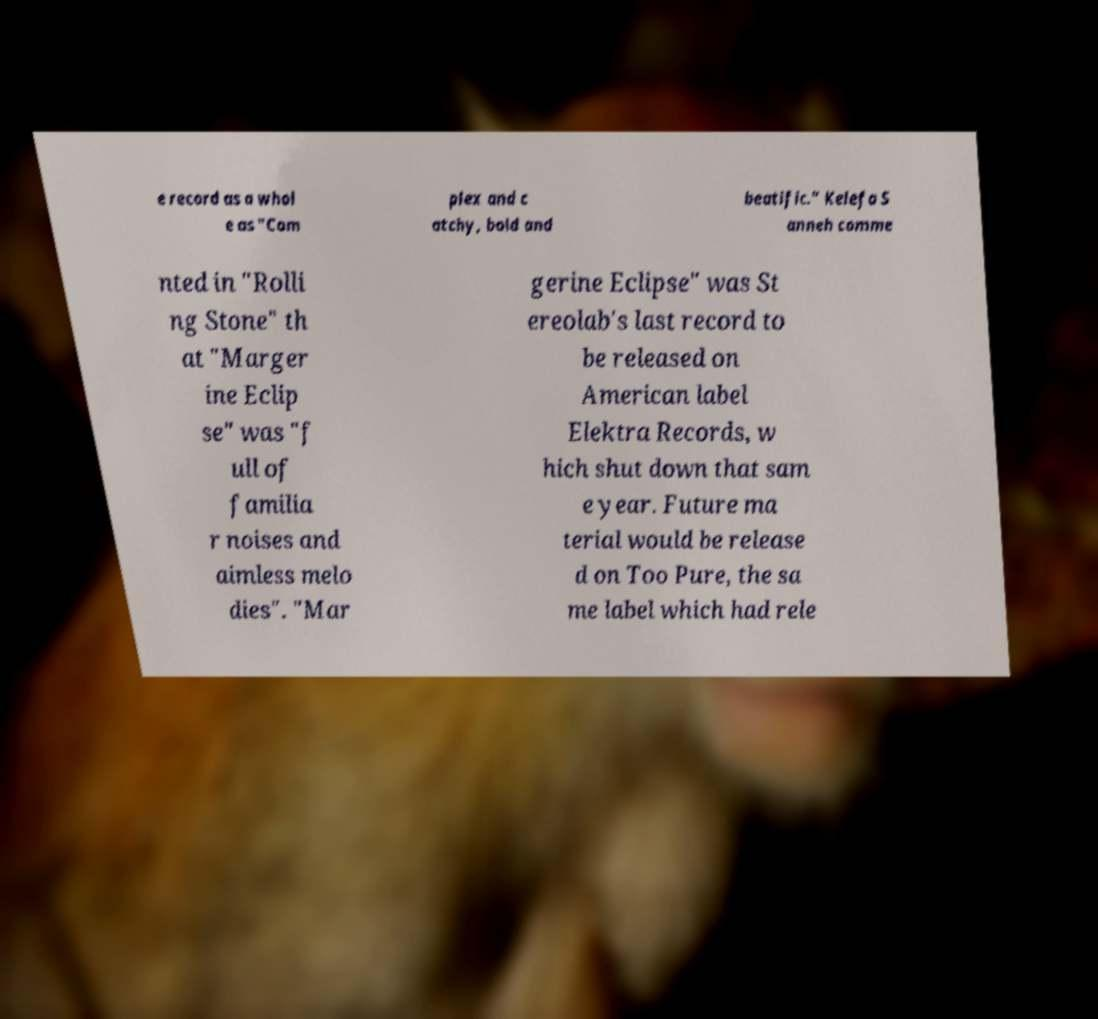Please identify and transcribe the text found in this image. e record as a whol e as "Com plex and c atchy, bold and beatific." Kelefa S anneh comme nted in "Rolli ng Stone" th at "Marger ine Eclip se" was "f ull of familia r noises and aimless melo dies". "Mar gerine Eclipse" was St ereolab's last record to be released on American label Elektra Records, w hich shut down that sam e year. Future ma terial would be release d on Too Pure, the sa me label which had rele 